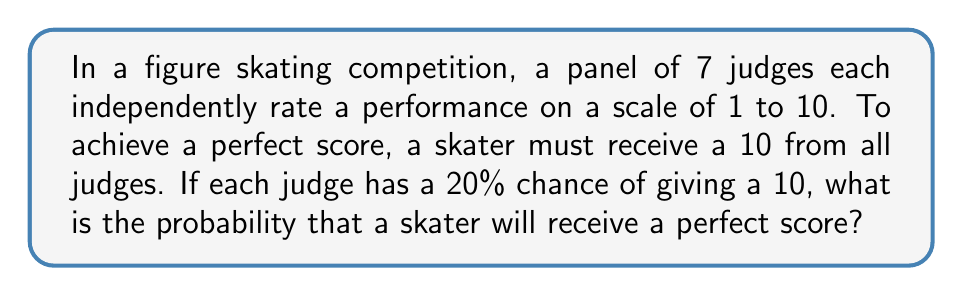Could you help me with this problem? Let's approach this step-by-step:

1) For a perfect score, we need all 7 judges to give a 10. This means we're looking for the probability of 7 independent events all occurring together.

2) The probability of each judge giving a 10 is 20% or 0.2.

3) When we want the probability of multiple independent events all occurring, we multiply their individual probabilities.

4) So, we need to calculate:

   $$(0.2)^7$$

5) This is because we're multiplying 0.2 by itself 7 times (once for each judge).

6) Let's calculate this:

   $$(0.2)^7 = 0.0000128$$

7) To convert to a percentage, we multiply by 100:

   $$0.0000128 * 100 = 0.00128\%$$

Therefore, the probability of achieving a perfect score is approximately 0.00128% or about 1 in 78,125.
Answer: $$(0.2)^7 \approx 0.00128\%$$ 